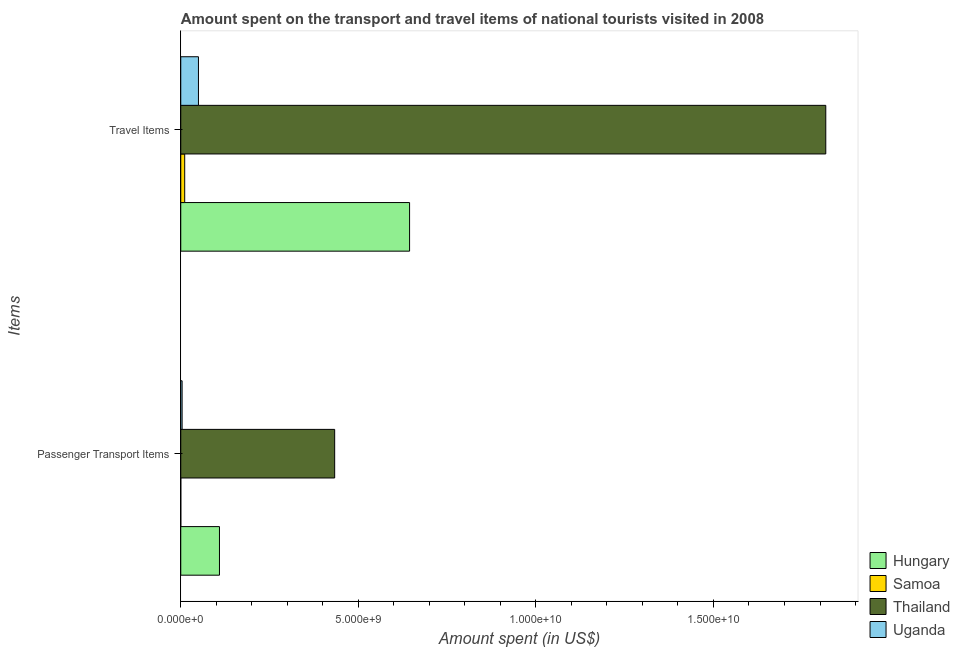How many different coloured bars are there?
Provide a succinct answer. 4. How many groups of bars are there?
Your response must be concise. 2. Are the number of bars per tick equal to the number of legend labels?
Offer a terse response. Yes. What is the label of the 1st group of bars from the top?
Make the answer very short. Travel Items. What is the amount spent on passenger transport items in Hungary?
Make the answer very short. 1.09e+09. Across all countries, what is the maximum amount spent in travel items?
Offer a terse response. 1.82e+1. Across all countries, what is the minimum amount spent on passenger transport items?
Make the answer very short. 6.00e+05. In which country was the amount spent in travel items maximum?
Your answer should be compact. Thailand. In which country was the amount spent in travel items minimum?
Provide a succinct answer. Samoa. What is the total amount spent in travel items in the graph?
Provide a succinct answer. 2.52e+1. What is the difference between the amount spent in travel items in Samoa and that in Uganda?
Offer a very short reply. -3.87e+08. What is the difference between the amount spent in travel items in Uganda and the amount spent on passenger transport items in Thailand?
Provide a short and direct response. -3.84e+09. What is the average amount spent on passenger transport items per country?
Make the answer very short. 1.37e+09. What is the difference between the amount spent in travel items and amount spent on passenger transport items in Thailand?
Provide a short and direct response. 1.38e+1. What is the ratio of the amount spent on passenger transport items in Thailand to that in Uganda?
Your answer should be compact. 114.05. Is the amount spent on passenger transport items in Hungary less than that in Thailand?
Your response must be concise. Yes. What does the 3rd bar from the top in Travel Items represents?
Offer a very short reply. Samoa. What does the 2nd bar from the bottom in Travel Items represents?
Offer a very short reply. Samoa. How many bars are there?
Keep it short and to the point. 8. Are the values on the major ticks of X-axis written in scientific E-notation?
Give a very brief answer. Yes. Does the graph contain any zero values?
Offer a terse response. No. How many legend labels are there?
Make the answer very short. 4. What is the title of the graph?
Your answer should be compact. Amount spent on the transport and travel items of national tourists visited in 2008. What is the label or title of the X-axis?
Your response must be concise. Amount spent (in US$). What is the label or title of the Y-axis?
Your answer should be compact. Items. What is the Amount spent (in US$) of Hungary in Passenger Transport Items?
Offer a terse response. 1.09e+09. What is the Amount spent (in US$) of Samoa in Passenger Transport Items?
Your answer should be compact. 6.00e+05. What is the Amount spent (in US$) in Thailand in Passenger Transport Items?
Give a very brief answer. 4.33e+09. What is the Amount spent (in US$) in Uganda in Passenger Transport Items?
Make the answer very short. 3.80e+07. What is the Amount spent (in US$) of Hungary in Travel Items?
Your answer should be very brief. 6.44e+09. What is the Amount spent (in US$) in Samoa in Travel Items?
Your response must be concise. 1.11e+08. What is the Amount spent (in US$) in Thailand in Travel Items?
Offer a very short reply. 1.82e+1. What is the Amount spent (in US$) in Uganda in Travel Items?
Your answer should be very brief. 4.98e+08. Across all Items, what is the maximum Amount spent (in US$) of Hungary?
Your answer should be very brief. 6.44e+09. Across all Items, what is the maximum Amount spent (in US$) of Samoa?
Your answer should be compact. 1.11e+08. Across all Items, what is the maximum Amount spent (in US$) in Thailand?
Ensure brevity in your answer.  1.82e+1. Across all Items, what is the maximum Amount spent (in US$) of Uganda?
Provide a short and direct response. 4.98e+08. Across all Items, what is the minimum Amount spent (in US$) in Hungary?
Your answer should be very brief. 1.09e+09. Across all Items, what is the minimum Amount spent (in US$) of Thailand?
Give a very brief answer. 4.33e+09. Across all Items, what is the minimum Amount spent (in US$) of Uganda?
Your answer should be compact. 3.80e+07. What is the total Amount spent (in US$) of Hungary in the graph?
Provide a succinct answer. 7.53e+09. What is the total Amount spent (in US$) in Samoa in the graph?
Ensure brevity in your answer.  1.12e+08. What is the total Amount spent (in US$) of Thailand in the graph?
Provide a short and direct response. 2.25e+1. What is the total Amount spent (in US$) in Uganda in the graph?
Your answer should be compact. 5.36e+08. What is the difference between the Amount spent (in US$) of Hungary in Passenger Transport Items and that in Travel Items?
Keep it short and to the point. -5.35e+09. What is the difference between the Amount spent (in US$) in Samoa in Passenger Transport Items and that in Travel Items?
Ensure brevity in your answer.  -1.10e+08. What is the difference between the Amount spent (in US$) of Thailand in Passenger Transport Items and that in Travel Items?
Offer a terse response. -1.38e+1. What is the difference between the Amount spent (in US$) of Uganda in Passenger Transport Items and that in Travel Items?
Ensure brevity in your answer.  -4.60e+08. What is the difference between the Amount spent (in US$) of Hungary in Passenger Transport Items and the Amount spent (in US$) of Samoa in Travel Items?
Provide a succinct answer. 9.79e+08. What is the difference between the Amount spent (in US$) of Hungary in Passenger Transport Items and the Amount spent (in US$) of Thailand in Travel Items?
Ensure brevity in your answer.  -1.71e+1. What is the difference between the Amount spent (in US$) in Hungary in Passenger Transport Items and the Amount spent (in US$) in Uganda in Travel Items?
Offer a terse response. 5.92e+08. What is the difference between the Amount spent (in US$) of Samoa in Passenger Transport Items and the Amount spent (in US$) of Thailand in Travel Items?
Your response must be concise. -1.82e+1. What is the difference between the Amount spent (in US$) of Samoa in Passenger Transport Items and the Amount spent (in US$) of Uganda in Travel Items?
Your answer should be compact. -4.97e+08. What is the difference between the Amount spent (in US$) of Thailand in Passenger Transport Items and the Amount spent (in US$) of Uganda in Travel Items?
Provide a succinct answer. 3.84e+09. What is the average Amount spent (in US$) of Hungary per Items?
Ensure brevity in your answer.  3.77e+09. What is the average Amount spent (in US$) in Samoa per Items?
Your answer should be very brief. 5.58e+07. What is the average Amount spent (in US$) in Thailand per Items?
Make the answer very short. 1.12e+1. What is the average Amount spent (in US$) in Uganda per Items?
Provide a short and direct response. 2.68e+08. What is the difference between the Amount spent (in US$) of Hungary and Amount spent (in US$) of Samoa in Passenger Transport Items?
Offer a terse response. 1.09e+09. What is the difference between the Amount spent (in US$) of Hungary and Amount spent (in US$) of Thailand in Passenger Transport Items?
Offer a very short reply. -3.24e+09. What is the difference between the Amount spent (in US$) of Hungary and Amount spent (in US$) of Uganda in Passenger Transport Items?
Your answer should be compact. 1.05e+09. What is the difference between the Amount spent (in US$) of Samoa and Amount spent (in US$) of Thailand in Passenger Transport Items?
Provide a short and direct response. -4.33e+09. What is the difference between the Amount spent (in US$) of Samoa and Amount spent (in US$) of Uganda in Passenger Transport Items?
Offer a terse response. -3.74e+07. What is the difference between the Amount spent (in US$) in Thailand and Amount spent (in US$) in Uganda in Passenger Transport Items?
Make the answer very short. 4.30e+09. What is the difference between the Amount spent (in US$) in Hungary and Amount spent (in US$) in Samoa in Travel Items?
Provide a succinct answer. 6.33e+09. What is the difference between the Amount spent (in US$) in Hungary and Amount spent (in US$) in Thailand in Travel Items?
Your response must be concise. -1.17e+1. What is the difference between the Amount spent (in US$) in Hungary and Amount spent (in US$) in Uganda in Travel Items?
Provide a short and direct response. 5.94e+09. What is the difference between the Amount spent (in US$) in Samoa and Amount spent (in US$) in Thailand in Travel Items?
Offer a terse response. -1.81e+1. What is the difference between the Amount spent (in US$) of Samoa and Amount spent (in US$) of Uganda in Travel Items?
Provide a succinct answer. -3.87e+08. What is the difference between the Amount spent (in US$) of Thailand and Amount spent (in US$) of Uganda in Travel Items?
Make the answer very short. 1.77e+1. What is the ratio of the Amount spent (in US$) of Hungary in Passenger Transport Items to that in Travel Items?
Your answer should be very brief. 0.17. What is the ratio of the Amount spent (in US$) in Samoa in Passenger Transport Items to that in Travel Items?
Provide a succinct answer. 0.01. What is the ratio of the Amount spent (in US$) of Thailand in Passenger Transport Items to that in Travel Items?
Offer a very short reply. 0.24. What is the ratio of the Amount spent (in US$) of Uganda in Passenger Transport Items to that in Travel Items?
Your answer should be very brief. 0.08. What is the difference between the highest and the second highest Amount spent (in US$) of Hungary?
Your answer should be very brief. 5.35e+09. What is the difference between the highest and the second highest Amount spent (in US$) in Samoa?
Keep it short and to the point. 1.10e+08. What is the difference between the highest and the second highest Amount spent (in US$) in Thailand?
Your answer should be compact. 1.38e+1. What is the difference between the highest and the second highest Amount spent (in US$) of Uganda?
Provide a short and direct response. 4.60e+08. What is the difference between the highest and the lowest Amount spent (in US$) of Hungary?
Offer a very short reply. 5.35e+09. What is the difference between the highest and the lowest Amount spent (in US$) in Samoa?
Your response must be concise. 1.10e+08. What is the difference between the highest and the lowest Amount spent (in US$) in Thailand?
Give a very brief answer. 1.38e+1. What is the difference between the highest and the lowest Amount spent (in US$) of Uganda?
Give a very brief answer. 4.60e+08. 